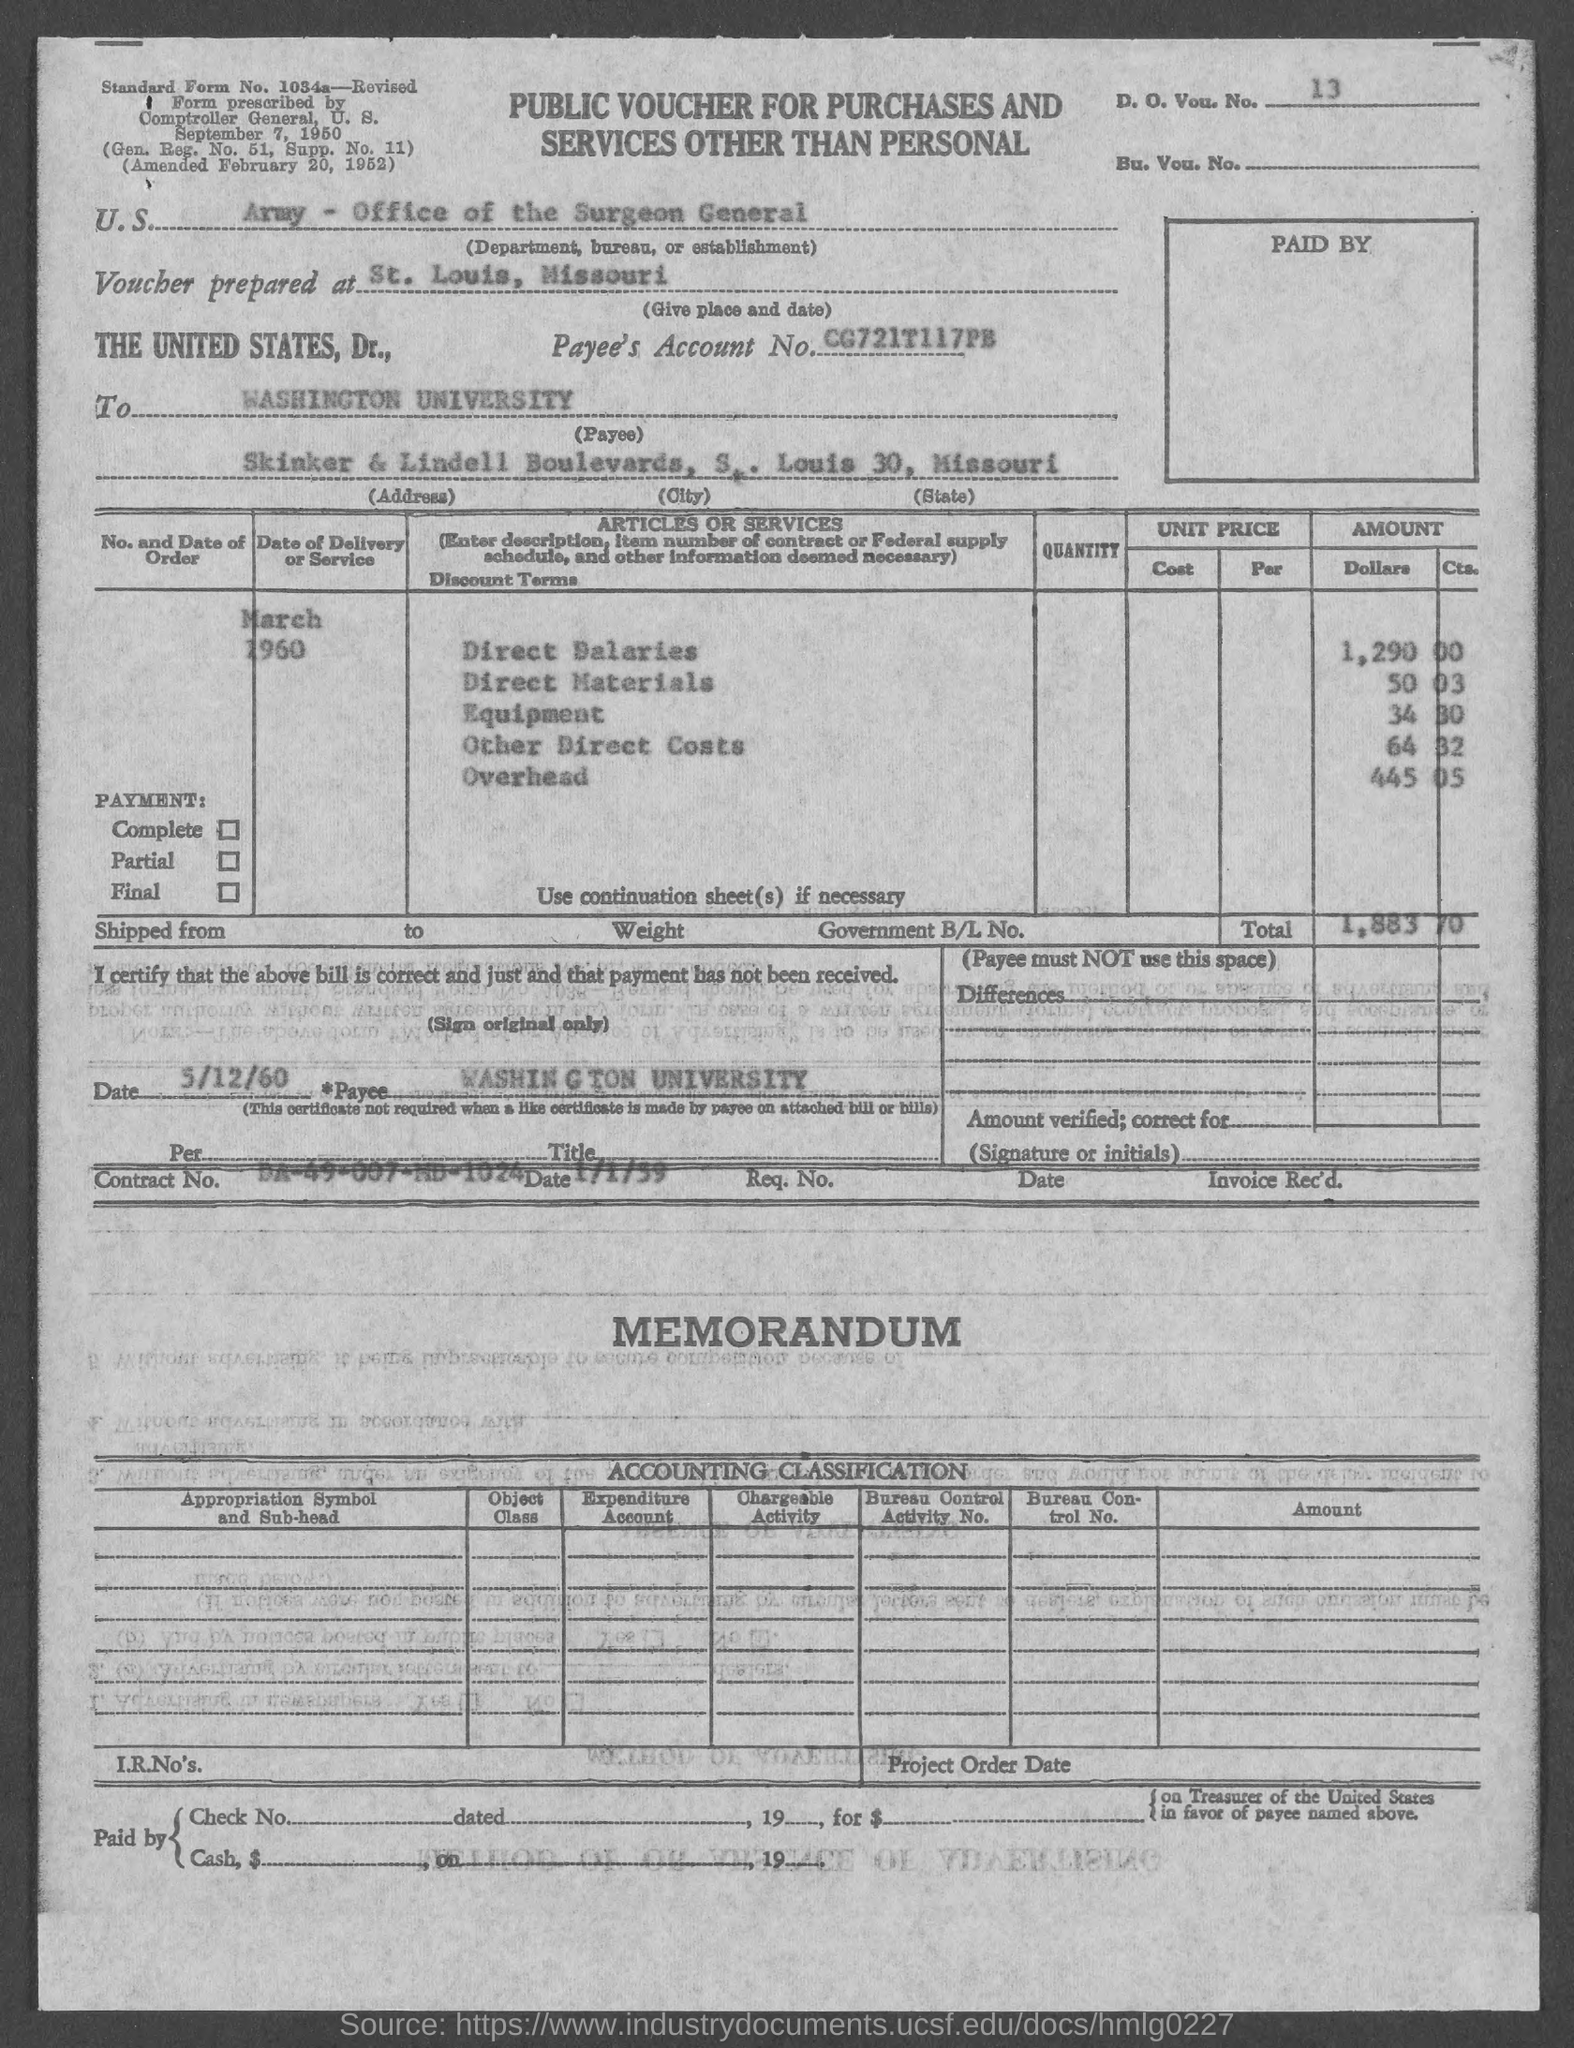What is the D. O. Vou. No. given in the document?
Ensure brevity in your answer.  13. What is the U.S. Department, Bureau, or Establishment given in the voucher?
Give a very brief answer. ARMY - Office of the Surgeon General. Where is the voucher prepared at?
Keep it short and to the point. ST. LOUIS, MISSOURI. What is the Payee's Account No. given in the voucher?
Your response must be concise. CG721T117PB. What is the payee name mentioned in the voucher?
Give a very brief answer. Washington university. What is the direct salaries cost mentioned in the voucher?
Keep it short and to the point. 1,290 00. What is the equipment cost given in the voucher?
Your response must be concise. 34 30. What is the Direct materials cost given in the voucher?
Provide a short and direct response. 50 03. What is the total amount mentioned in the voucher?
Your answer should be compact. $1,883.70. What is the Contract No. given in the voucher?
Provide a short and direct response. DA-49-007-MD-1024. 